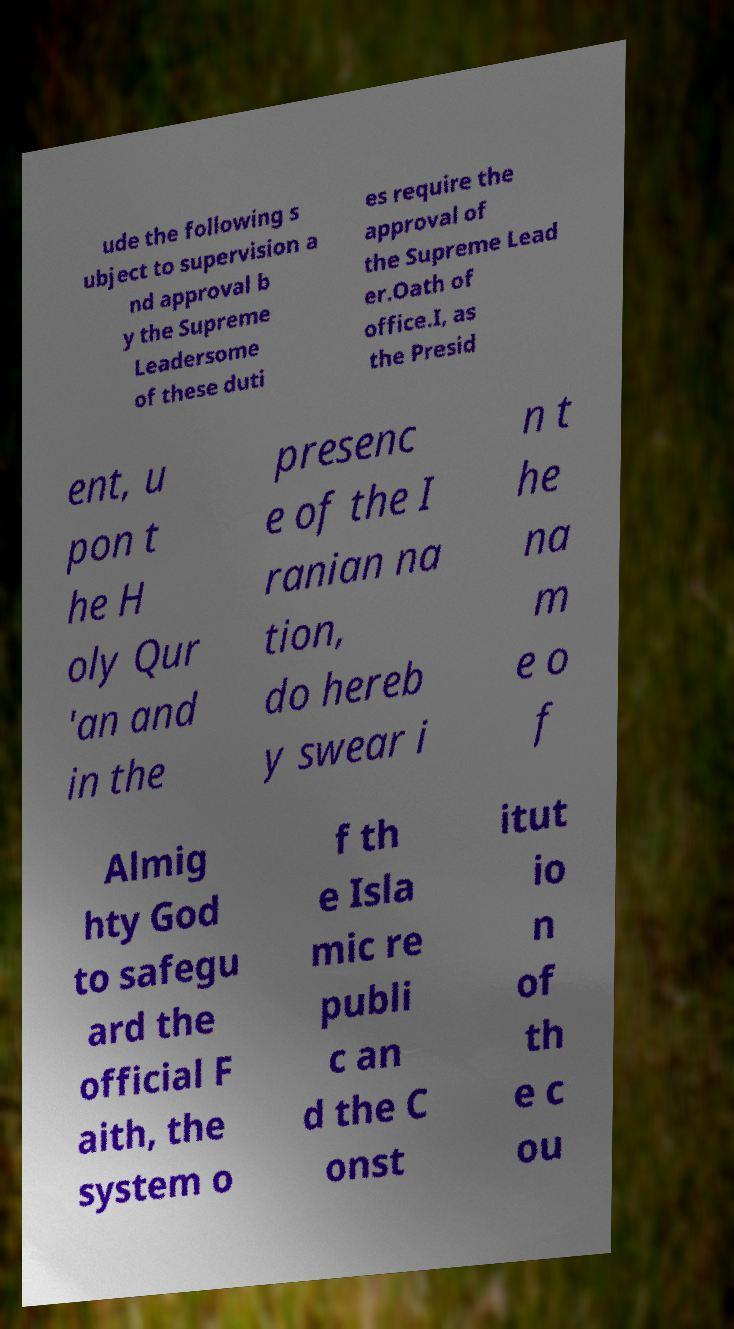I need the written content from this picture converted into text. Can you do that? ude the following s ubject to supervision a nd approval b y the Supreme Leadersome of these duti es require the approval of the Supreme Lead er.Oath of office.I, as the Presid ent, u pon t he H oly Qur 'an and in the presenc e of the I ranian na tion, do hereb y swear i n t he na m e o f Almig hty God to safegu ard the official F aith, the system o f th e Isla mic re publi c an d the C onst itut io n of th e c ou 